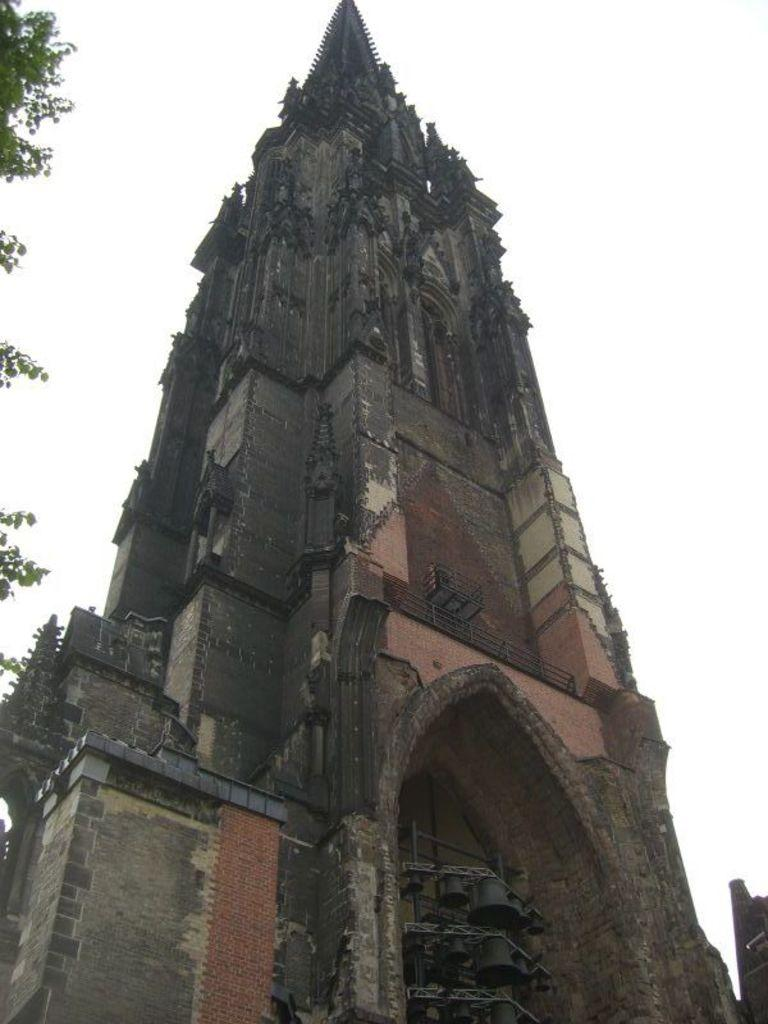What is the main structure in the image? There is a monument in the image. What type of natural element is present in the image? There is a tree in the image. What is the condition of the stream in the image? There is no stream present in the image; it only features a monument and a tree. How many geese can be seen interacting with the monument in the image? There are no geese present in the image. 